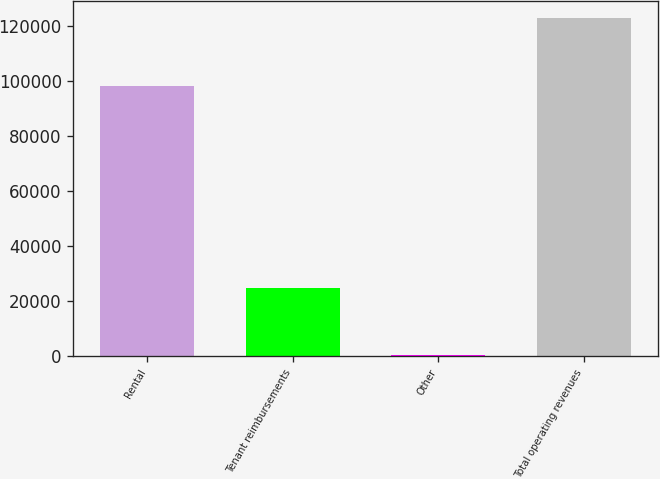<chart> <loc_0><loc_0><loc_500><loc_500><bar_chart><fcel>Rental<fcel>Tenant reimbursements<fcel>Other<fcel>Total operating revenues<nl><fcel>98232<fcel>24663<fcel>276<fcel>123171<nl></chart> 